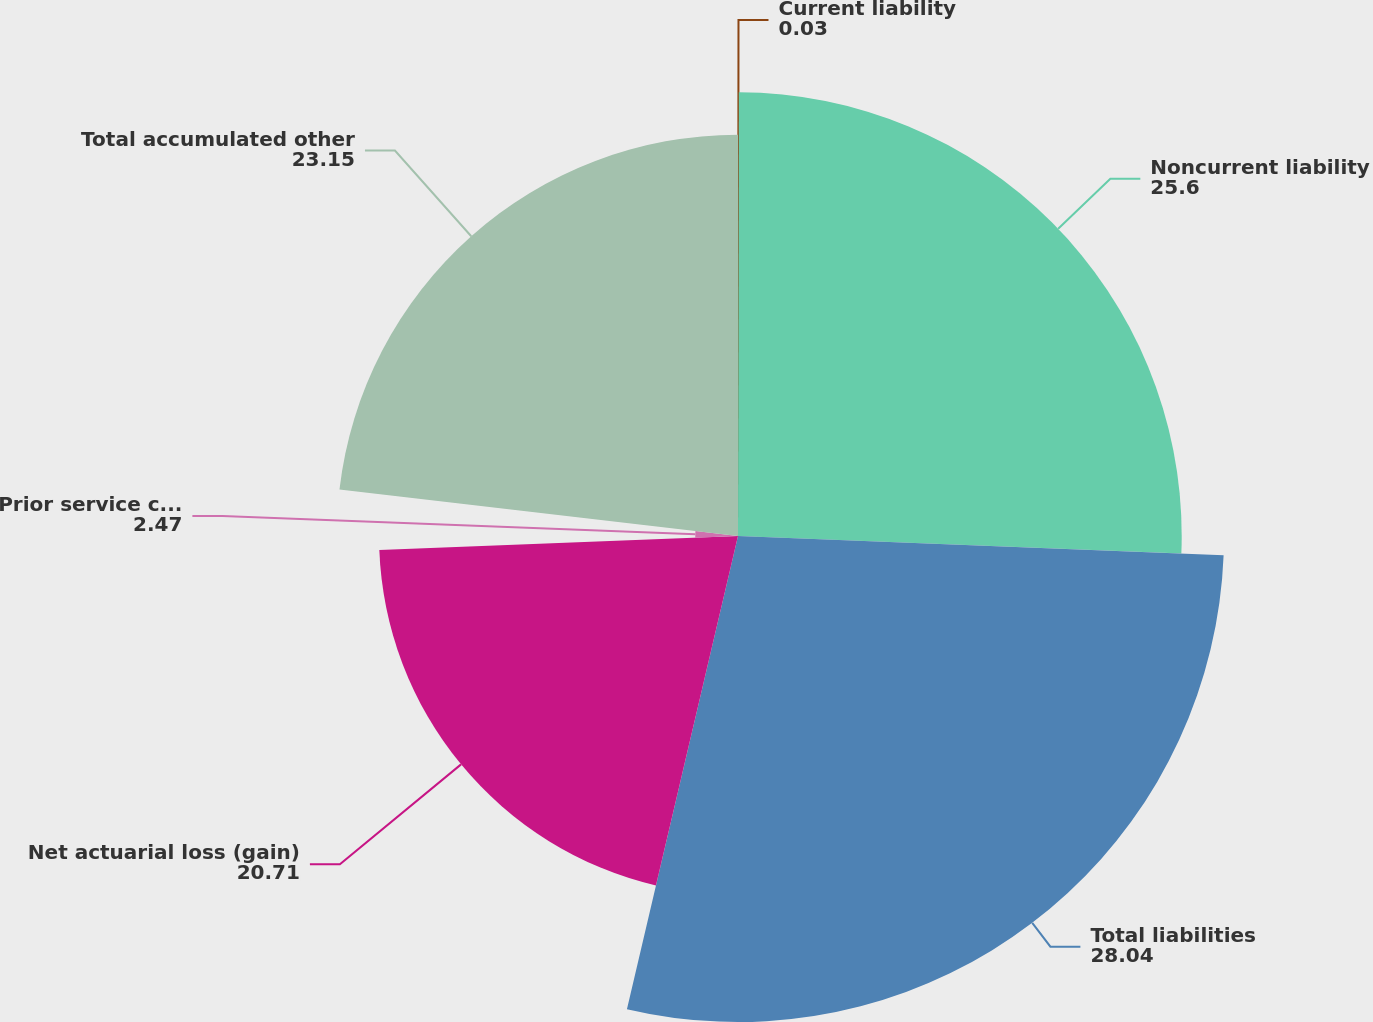<chart> <loc_0><loc_0><loc_500><loc_500><pie_chart><fcel>Current liability<fcel>Noncurrent liability<fcel>Total liabilities<fcel>Net actuarial loss (gain)<fcel>Prior service cost (benefit)<fcel>Total accumulated other<nl><fcel>0.03%<fcel>25.6%<fcel>28.04%<fcel>20.71%<fcel>2.47%<fcel>23.15%<nl></chart> 